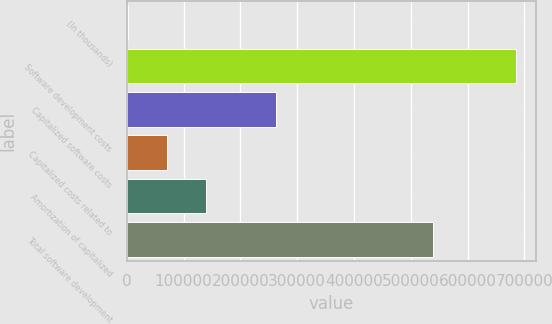Convert chart. <chart><loc_0><loc_0><loc_500><loc_500><bar_chart><fcel>(In thousands)<fcel>Software development costs<fcel>Capitalized software costs<fcel>Capitalized costs related to<fcel>Amortization of capitalized<fcel>Total software development<nl><fcel>2015<fcel>685260<fcel>262177<fcel>70339.5<fcel>138664<fcel>539799<nl></chart> 